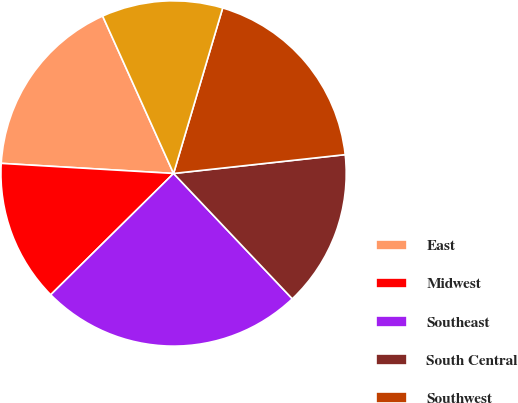Convert chart. <chart><loc_0><loc_0><loc_500><loc_500><pie_chart><fcel>East<fcel>Midwest<fcel>Southeast<fcel>South Central<fcel>Southwest<fcel>West<nl><fcel>17.33%<fcel>13.33%<fcel>24.67%<fcel>14.67%<fcel>18.67%<fcel>11.33%<nl></chart> 